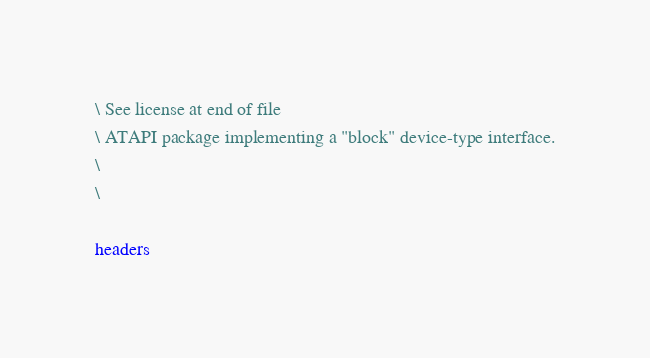Convert code to text. <code><loc_0><loc_0><loc_500><loc_500><_Forth_>\ See license at end of file
\ ATAPI package implementing a "block" device-type interface.
\
\

headers
</code> 